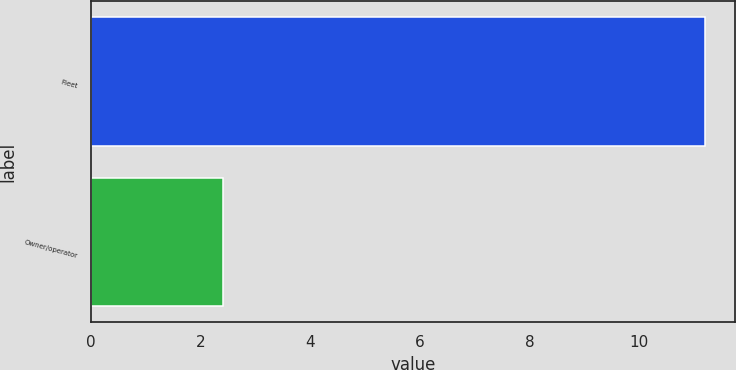Convert chart. <chart><loc_0><loc_0><loc_500><loc_500><bar_chart><fcel>Fleet<fcel>Owner/operator<nl><fcel>11.2<fcel>2.4<nl></chart> 